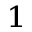Convert formula to latex. <formula><loc_0><loc_0><loc_500><loc_500>_ { 1 }</formula> 